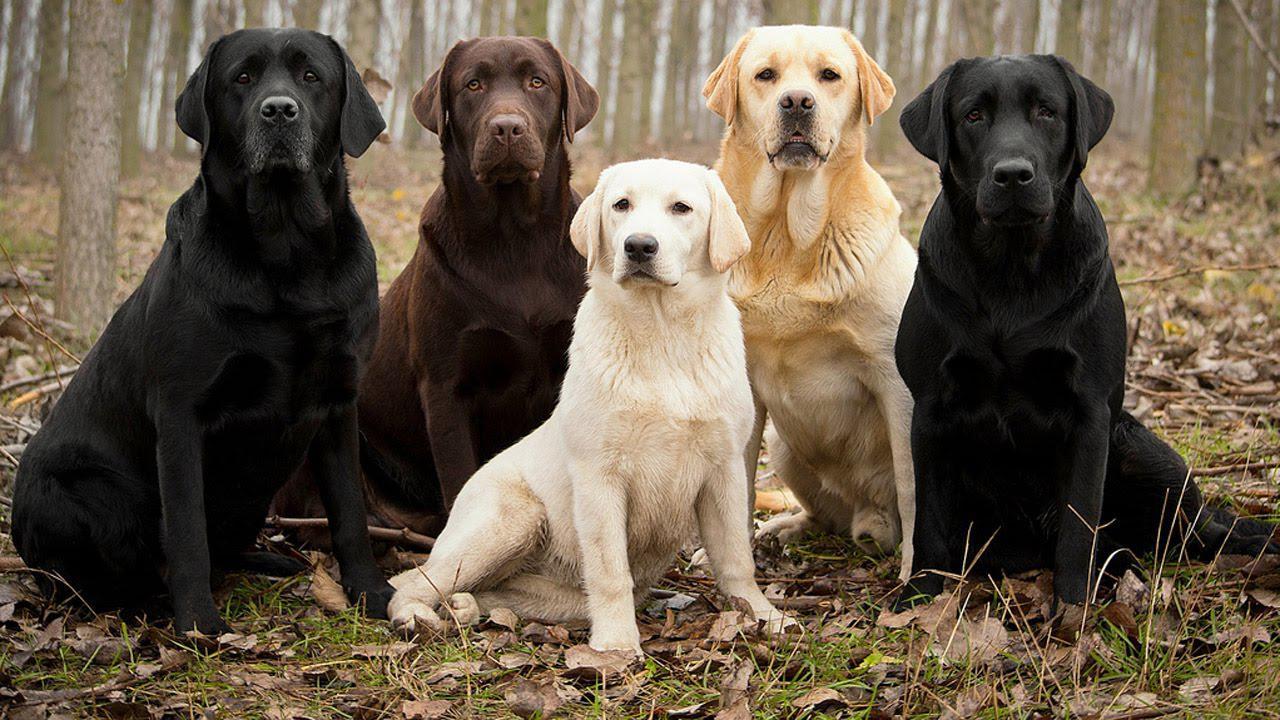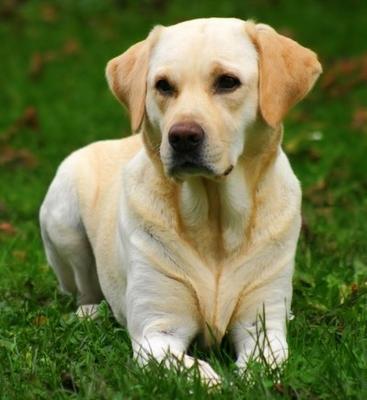The first image is the image on the left, the second image is the image on the right. Evaluate the accuracy of this statement regarding the images: "the dog on the right image has its mouth open". Is it true? Answer yes or no. No. 